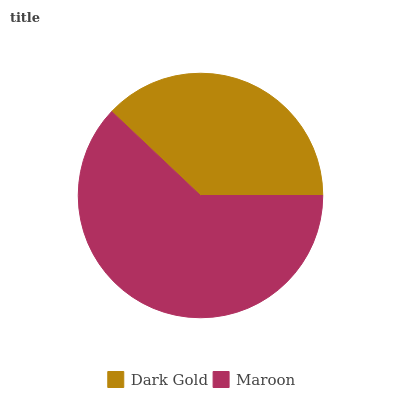Is Dark Gold the minimum?
Answer yes or no. Yes. Is Maroon the maximum?
Answer yes or no. Yes. Is Maroon the minimum?
Answer yes or no. No. Is Maroon greater than Dark Gold?
Answer yes or no. Yes. Is Dark Gold less than Maroon?
Answer yes or no. Yes. Is Dark Gold greater than Maroon?
Answer yes or no. No. Is Maroon less than Dark Gold?
Answer yes or no. No. Is Maroon the high median?
Answer yes or no. Yes. Is Dark Gold the low median?
Answer yes or no. Yes. Is Dark Gold the high median?
Answer yes or no. No. Is Maroon the low median?
Answer yes or no. No. 